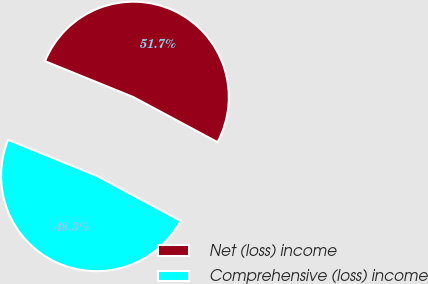Convert chart to OTSL. <chart><loc_0><loc_0><loc_500><loc_500><pie_chart><fcel>Net (loss) income<fcel>Comprehensive (loss) income<nl><fcel>51.68%<fcel>48.32%<nl></chart> 